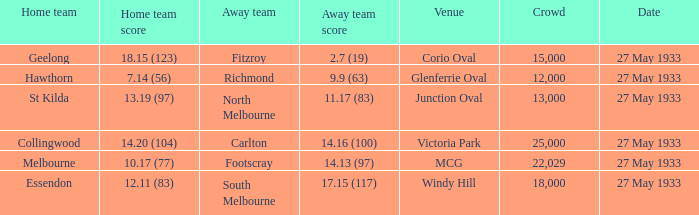Give me the full table as a dictionary. {'header': ['Home team', 'Home team score', 'Away team', 'Away team score', 'Venue', 'Crowd', 'Date'], 'rows': [['Geelong', '18.15 (123)', 'Fitzroy', '2.7 (19)', 'Corio Oval', '15,000', '27 May 1933'], ['Hawthorn', '7.14 (56)', 'Richmond', '9.9 (63)', 'Glenferrie Oval', '12,000', '27 May 1933'], ['St Kilda', '13.19 (97)', 'North Melbourne', '11.17 (83)', 'Junction Oval', '13,000', '27 May 1933'], ['Collingwood', '14.20 (104)', 'Carlton', '14.16 (100)', 'Victoria Park', '25,000', '27 May 1933'], ['Melbourne', '10.17 (77)', 'Footscray', '14.13 (97)', 'MCG', '22,029', '27 May 1933'], ['Essendon', '12.11 (83)', 'South Melbourne', '17.15 (117)', 'Windy Hill', '18,000', '27 May 1933']]} In the match where the home team scored 14.20 (104), how many attendees were in the crowd? 25000.0. 